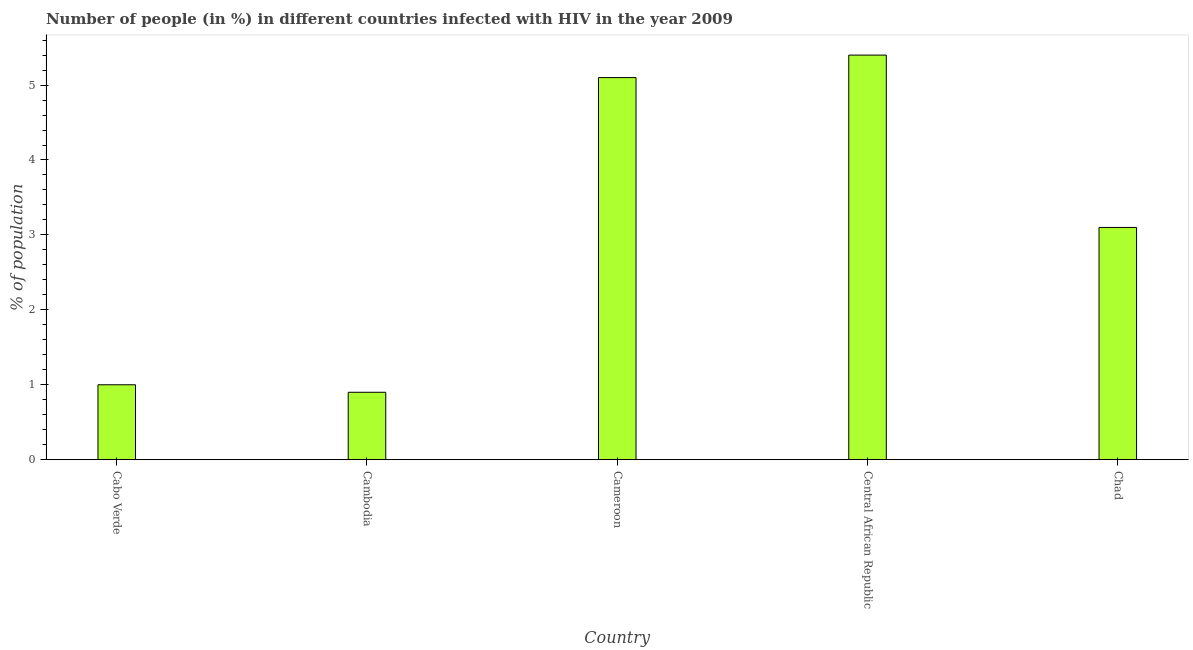Does the graph contain any zero values?
Ensure brevity in your answer.  No. Does the graph contain grids?
Your answer should be compact. No. What is the title of the graph?
Your answer should be compact. Number of people (in %) in different countries infected with HIV in the year 2009. What is the label or title of the X-axis?
Make the answer very short. Country. What is the label or title of the Y-axis?
Your answer should be compact. % of population. What is the number of people infected with hiv in Cambodia?
Your answer should be very brief. 0.9. Across all countries, what is the minimum number of people infected with hiv?
Provide a succinct answer. 0.9. In which country was the number of people infected with hiv maximum?
Offer a very short reply. Central African Republic. In which country was the number of people infected with hiv minimum?
Your answer should be very brief. Cambodia. What is the ratio of the number of people infected with hiv in Cabo Verde to that in Central African Republic?
Provide a succinct answer. 0.18. Is the number of people infected with hiv in Cabo Verde less than that in Cameroon?
Offer a very short reply. Yes. Is the difference between the number of people infected with hiv in Cabo Verde and Cameroon greater than the difference between any two countries?
Your response must be concise. No. What is the difference between the highest and the second highest number of people infected with hiv?
Make the answer very short. 0.3. What is the difference between the highest and the lowest number of people infected with hiv?
Provide a short and direct response. 4.5. How many bars are there?
Provide a short and direct response. 5. Are all the bars in the graph horizontal?
Your answer should be compact. No. What is the difference between two consecutive major ticks on the Y-axis?
Offer a terse response. 1. Are the values on the major ticks of Y-axis written in scientific E-notation?
Your answer should be compact. No. What is the % of population in Cabo Verde?
Give a very brief answer. 1. What is the % of population of Central African Republic?
Provide a short and direct response. 5.4. What is the difference between the % of population in Cambodia and Cameroon?
Your response must be concise. -4.2. What is the difference between the % of population in Cambodia and Central African Republic?
Your answer should be very brief. -4.5. What is the difference between the % of population in Cameroon and Chad?
Your answer should be compact. 2. What is the difference between the % of population in Central African Republic and Chad?
Ensure brevity in your answer.  2.3. What is the ratio of the % of population in Cabo Verde to that in Cambodia?
Ensure brevity in your answer.  1.11. What is the ratio of the % of population in Cabo Verde to that in Cameroon?
Keep it short and to the point. 0.2. What is the ratio of the % of population in Cabo Verde to that in Central African Republic?
Give a very brief answer. 0.18. What is the ratio of the % of population in Cabo Verde to that in Chad?
Keep it short and to the point. 0.32. What is the ratio of the % of population in Cambodia to that in Cameroon?
Provide a short and direct response. 0.18. What is the ratio of the % of population in Cambodia to that in Central African Republic?
Offer a terse response. 0.17. What is the ratio of the % of population in Cambodia to that in Chad?
Give a very brief answer. 0.29. What is the ratio of the % of population in Cameroon to that in Central African Republic?
Your answer should be very brief. 0.94. What is the ratio of the % of population in Cameroon to that in Chad?
Provide a short and direct response. 1.65. What is the ratio of the % of population in Central African Republic to that in Chad?
Your answer should be very brief. 1.74. 